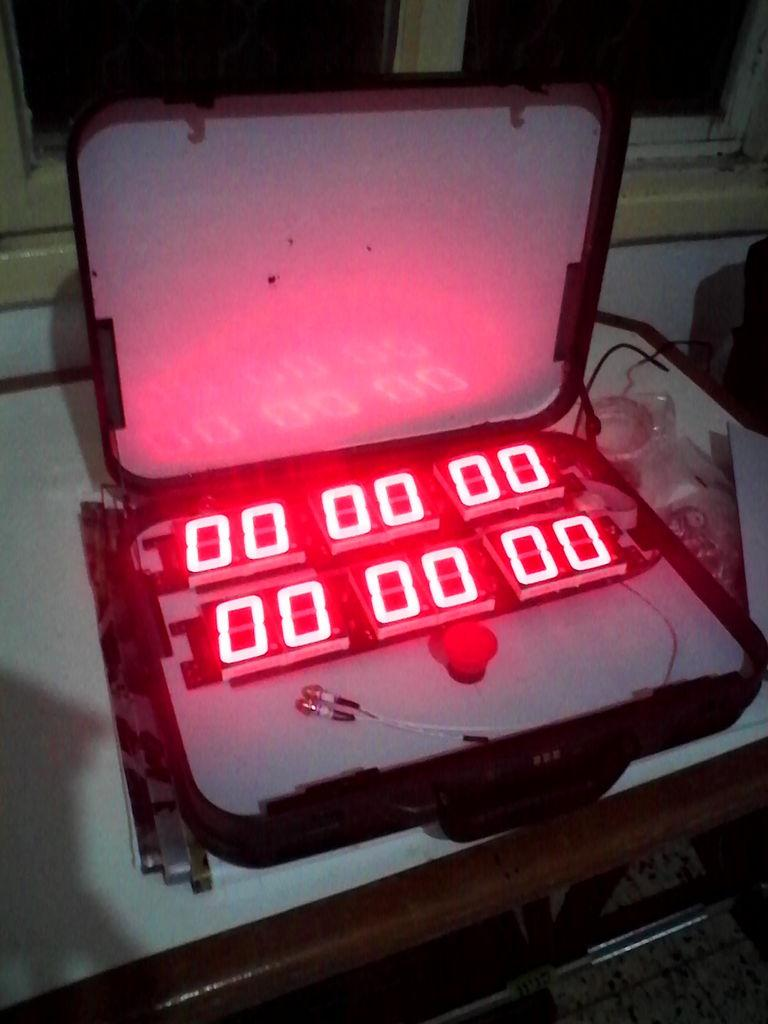What is inside the box that is visible in the image? There is a led display inside a box in the image. What can be seen in the background of the image? There are windows and a desk visible in the background of the image. What is the surface that the box and desk are placed on in the image? There is a floor visible in the image. What plot is the beggar trying to convey in the image? There is no beggar present in the image, and therefore no plot can be determined. How does the grip of the person holding the led display affect the image? There is no person holding the led display in the image, so the grip cannot be assessed. 